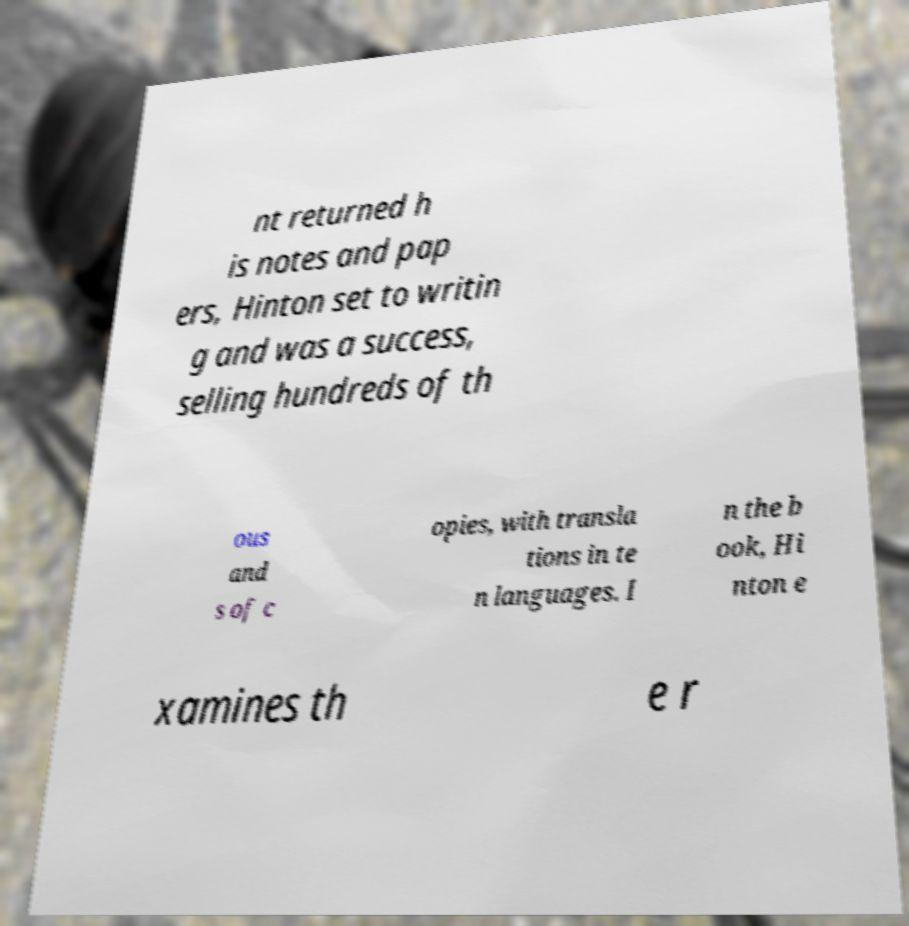For documentation purposes, I need the text within this image transcribed. Could you provide that? nt returned h is notes and pap ers, Hinton set to writin g and was a success, selling hundreds of th ous and s of c opies, with transla tions in te n languages. I n the b ook, Hi nton e xamines th e r 